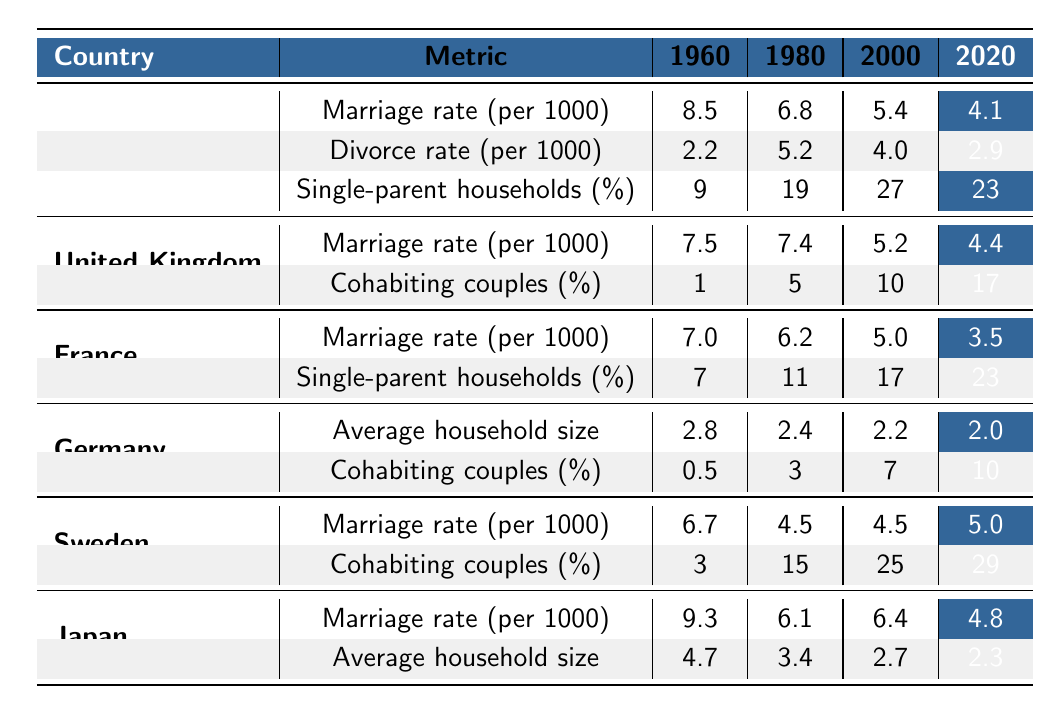What was the marriage rate in the United States in 1960? The table indicates that the marriage rate in the United States in 1960 was 8.5 per 1000.
Answer: 8.5 Which country had the highest divorce rate in 1980? By comparing the divorce rates in 1980, the United States had a divorce rate of 5.2, which is higher than the other countries listed.
Answer: United States What percentage of single-parent households was recorded in France in 2020? The table reflects that, in France, the percentage of single-parent households in 2020 was 23%.
Answer: 23% What is the average household size in Germany by 2020? The table shows that the average household size in Germany decreased to 2.0 by 2020.
Answer: 2.0 Did the marriage rate in Sweden increase or decrease from 2000 to 2020? The marriage rate in Sweden was 4.5 in 2000 and remained the same in 2020. Thus, it did not change.
Answer: No change How does the divorce rate in the United States compare to that in the United Kingdom in 2000? In 2000, the United States had a divorce rate of 4.0, while the United Kingdom's rate was lower at 2.5, indicating that the US had a higher divorce rate.
Answer: Higher in the United States What is the percentage of cohabiting couples in the United Kingdom in 2020 compared to 1980? In 2020, the percentage of cohabiting couples was 17%, which is an increase from 5% in 1980. Hence, this shows a growing trend.
Answer: Increased What can be inferred about the trend of single-parent households in the United States from 1960 to 2020? The single-parent households increased from 9% in 1960 to 23% in 2020, indicating a significant upward trend over the years.
Answer: Significant increase What was the percentage of cohabiting couples in Germany in 2020 compared to France? In 2020, Germany had 10% of cohabiting couples, while France had an unspecified percentage, so a direct comparison cannot be made without additional data for France in that year.
Answer: Indeterminate without France's data Calculate the average marriage rate for the United States from 1960 to 2020. The marriage rates for the United States are 8.5, 6.8, 5.4, and 4.1. Adding these together gives 24.8, and dividing by 4, the average marriage rate is 6.2 per 1000.
Answer: 6.2 Was there an overall decline in the marriage rate across all countries provided from 1960 to 2020? Yes, all countries featured in the table show a decline in marriage rates from 1960 to 2020, confirming a general downward trend.
Answer: Yes 